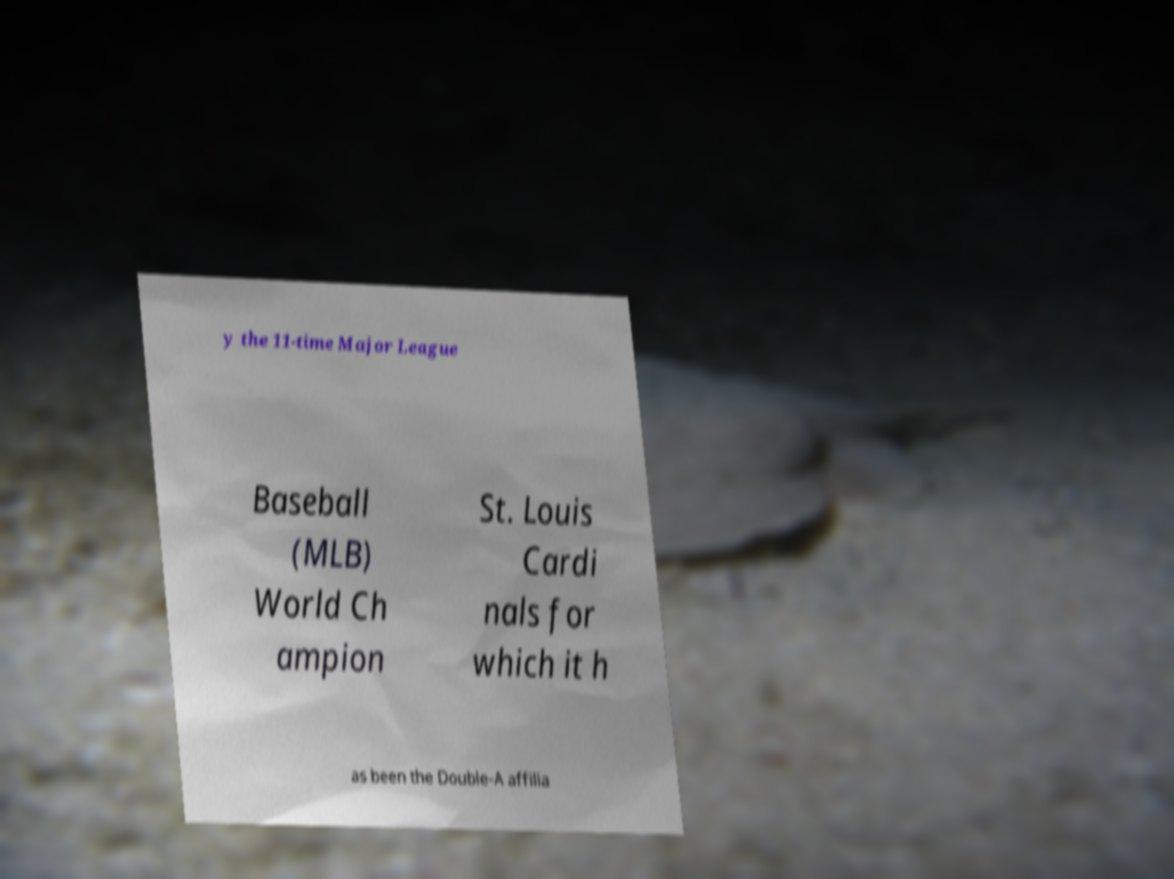I need the written content from this picture converted into text. Can you do that? y the 11-time Major League Baseball (MLB) World Ch ampion St. Louis Cardi nals for which it h as been the Double-A affilia 